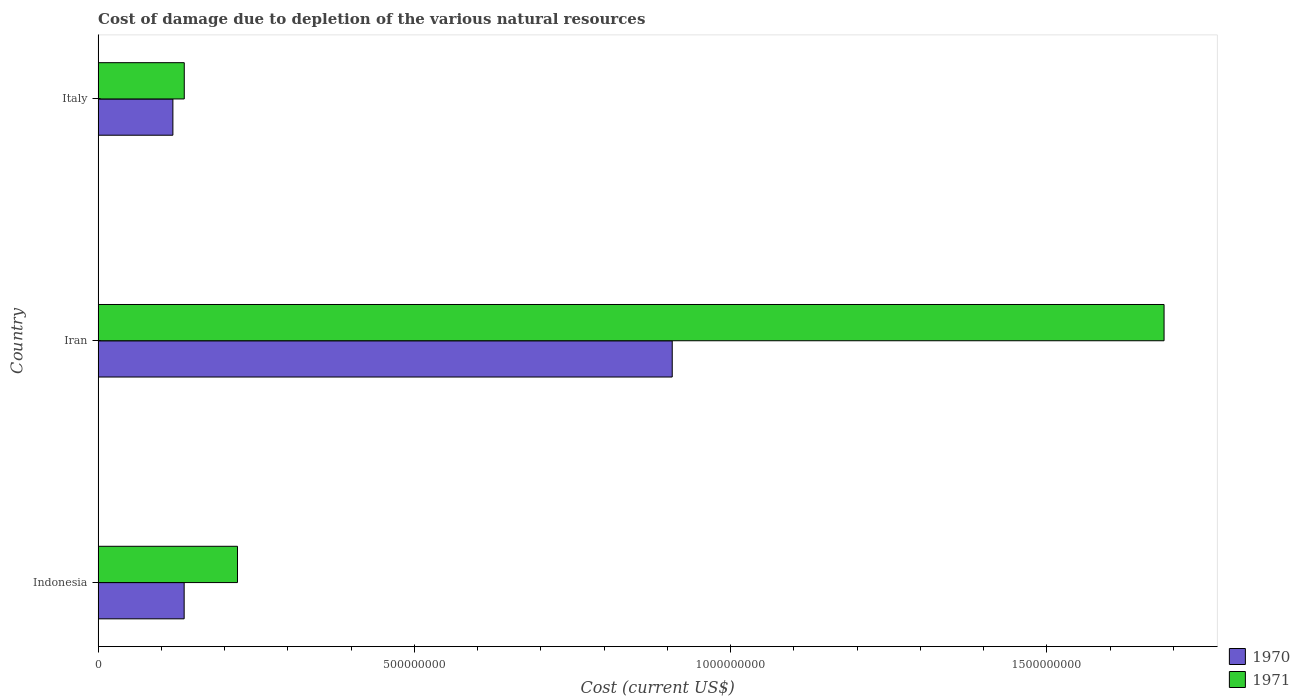How many different coloured bars are there?
Give a very brief answer. 2. How many groups of bars are there?
Keep it short and to the point. 3. Are the number of bars per tick equal to the number of legend labels?
Your answer should be compact. Yes. Are the number of bars on each tick of the Y-axis equal?
Ensure brevity in your answer.  Yes. How many bars are there on the 1st tick from the top?
Provide a short and direct response. 2. How many bars are there on the 1st tick from the bottom?
Provide a succinct answer. 2. In how many cases, is the number of bars for a given country not equal to the number of legend labels?
Provide a short and direct response. 0. What is the cost of damage caused due to the depletion of various natural resources in 1970 in Italy?
Offer a terse response. 1.18e+08. Across all countries, what is the maximum cost of damage caused due to the depletion of various natural resources in 1971?
Your answer should be compact. 1.69e+09. Across all countries, what is the minimum cost of damage caused due to the depletion of various natural resources in 1970?
Your answer should be compact. 1.18e+08. In which country was the cost of damage caused due to the depletion of various natural resources in 1971 maximum?
Ensure brevity in your answer.  Iran. In which country was the cost of damage caused due to the depletion of various natural resources in 1971 minimum?
Your answer should be compact. Italy. What is the total cost of damage caused due to the depletion of various natural resources in 1971 in the graph?
Your answer should be compact. 2.04e+09. What is the difference between the cost of damage caused due to the depletion of various natural resources in 1971 in Indonesia and that in Iran?
Ensure brevity in your answer.  -1.46e+09. What is the difference between the cost of damage caused due to the depletion of various natural resources in 1970 in Iran and the cost of damage caused due to the depletion of various natural resources in 1971 in Italy?
Make the answer very short. 7.71e+08. What is the average cost of damage caused due to the depletion of various natural resources in 1970 per country?
Keep it short and to the point. 3.87e+08. What is the difference between the cost of damage caused due to the depletion of various natural resources in 1971 and cost of damage caused due to the depletion of various natural resources in 1970 in Iran?
Offer a terse response. 7.78e+08. In how many countries, is the cost of damage caused due to the depletion of various natural resources in 1970 greater than 1300000000 US$?
Your answer should be very brief. 0. What is the ratio of the cost of damage caused due to the depletion of various natural resources in 1970 in Indonesia to that in Italy?
Provide a succinct answer. 1.15. Is the difference between the cost of damage caused due to the depletion of various natural resources in 1971 in Indonesia and Iran greater than the difference between the cost of damage caused due to the depletion of various natural resources in 1970 in Indonesia and Iran?
Your answer should be compact. No. What is the difference between the highest and the second highest cost of damage caused due to the depletion of various natural resources in 1970?
Offer a very short reply. 7.72e+08. What is the difference between the highest and the lowest cost of damage caused due to the depletion of various natural resources in 1971?
Offer a terse response. 1.55e+09. In how many countries, is the cost of damage caused due to the depletion of various natural resources in 1971 greater than the average cost of damage caused due to the depletion of various natural resources in 1971 taken over all countries?
Your response must be concise. 1. What does the 1st bar from the top in Indonesia represents?
Keep it short and to the point. 1971. What does the 1st bar from the bottom in Iran represents?
Provide a short and direct response. 1970. How many bars are there?
Offer a very short reply. 6. Are all the bars in the graph horizontal?
Your response must be concise. Yes. Does the graph contain grids?
Provide a short and direct response. No. How many legend labels are there?
Provide a short and direct response. 2. How are the legend labels stacked?
Ensure brevity in your answer.  Vertical. What is the title of the graph?
Provide a succinct answer. Cost of damage due to depletion of the various natural resources. What is the label or title of the X-axis?
Provide a short and direct response. Cost (current US$). What is the Cost (current US$) in 1970 in Indonesia?
Provide a short and direct response. 1.36e+08. What is the Cost (current US$) in 1971 in Indonesia?
Give a very brief answer. 2.20e+08. What is the Cost (current US$) in 1970 in Iran?
Keep it short and to the point. 9.08e+08. What is the Cost (current US$) in 1971 in Iran?
Ensure brevity in your answer.  1.69e+09. What is the Cost (current US$) in 1970 in Italy?
Give a very brief answer. 1.18e+08. What is the Cost (current US$) of 1971 in Italy?
Provide a succinct answer. 1.36e+08. Across all countries, what is the maximum Cost (current US$) of 1970?
Provide a short and direct response. 9.08e+08. Across all countries, what is the maximum Cost (current US$) of 1971?
Keep it short and to the point. 1.69e+09. Across all countries, what is the minimum Cost (current US$) in 1970?
Your answer should be compact. 1.18e+08. Across all countries, what is the minimum Cost (current US$) of 1971?
Offer a terse response. 1.36e+08. What is the total Cost (current US$) of 1970 in the graph?
Your answer should be compact. 1.16e+09. What is the total Cost (current US$) in 1971 in the graph?
Provide a short and direct response. 2.04e+09. What is the difference between the Cost (current US$) in 1970 in Indonesia and that in Iran?
Your answer should be compact. -7.72e+08. What is the difference between the Cost (current US$) of 1971 in Indonesia and that in Iran?
Provide a short and direct response. -1.46e+09. What is the difference between the Cost (current US$) in 1970 in Indonesia and that in Italy?
Give a very brief answer. 1.78e+07. What is the difference between the Cost (current US$) of 1971 in Indonesia and that in Italy?
Ensure brevity in your answer.  8.41e+07. What is the difference between the Cost (current US$) in 1970 in Iran and that in Italy?
Make the answer very short. 7.89e+08. What is the difference between the Cost (current US$) in 1971 in Iran and that in Italy?
Your answer should be compact. 1.55e+09. What is the difference between the Cost (current US$) in 1970 in Indonesia and the Cost (current US$) in 1971 in Iran?
Give a very brief answer. -1.55e+09. What is the difference between the Cost (current US$) of 1970 in Indonesia and the Cost (current US$) of 1971 in Italy?
Provide a succinct answer. -1.72e+05. What is the difference between the Cost (current US$) in 1970 in Iran and the Cost (current US$) in 1971 in Italy?
Make the answer very short. 7.71e+08. What is the average Cost (current US$) of 1970 per country?
Offer a terse response. 3.87e+08. What is the average Cost (current US$) in 1971 per country?
Keep it short and to the point. 6.81e+08. What is the difference between the Cost (current US$) in 1970 and Cost (current US$) in 1971 in Indonesia?
Offer a very short reply. -8.43e+07. What is the difference between the Cost (current US$) of 1970 and Cost (current US$) of 1971 in Iran?
Keep it short and to the point. -7.78e+08. What is the difference between the Cost (current US$) in 1970 and Cost (current US$) in 1971 in Italy?
Your answer should be very brief. -1.80e+07. What is the ratio of the Cost (current US$) of 1970 in Indonesia to that in Iran?
Your answer should be very brief. 0.15. What is the ratio of the Cost (current US$) of 1971 in Indonesia to that in Iran?
Provide a short and direct response. 0.13. What is the ratio of the Cost (current US$) in 1970 in Indonesia to that in Italy?
Offer a terse response. 1.15. What is the ratio of the Cost (current US$) of 1971 in Indonesia to that in Italy?
Keep it short and to the point. 1.62. What is the ratio of the Cost (current US$) in 1970 in Iran to that in Italy?
Ensure brevity in your answer.  7.68. What is the ratio of the Cost (current US$) in 1971 in Iran to that in Italy?
Offer a terse response. 12.37. What is the difference between the highest and the second highest Cost (current US$) in 1970?
Your answer should be compact. 7.72e+08. What is the difference between the highest and the second highest Cost (current US$) of 1971?
Make the answer very short. 1.46e+09. What is the difference between the highest and the lowest Cost (current US$) of 1970?
Make the answer very short. 7.89e+08. What is the difference between the highest and the lowest Cost (current US$) in 1971?
Provide a succinct answer. 1.55e+09. 